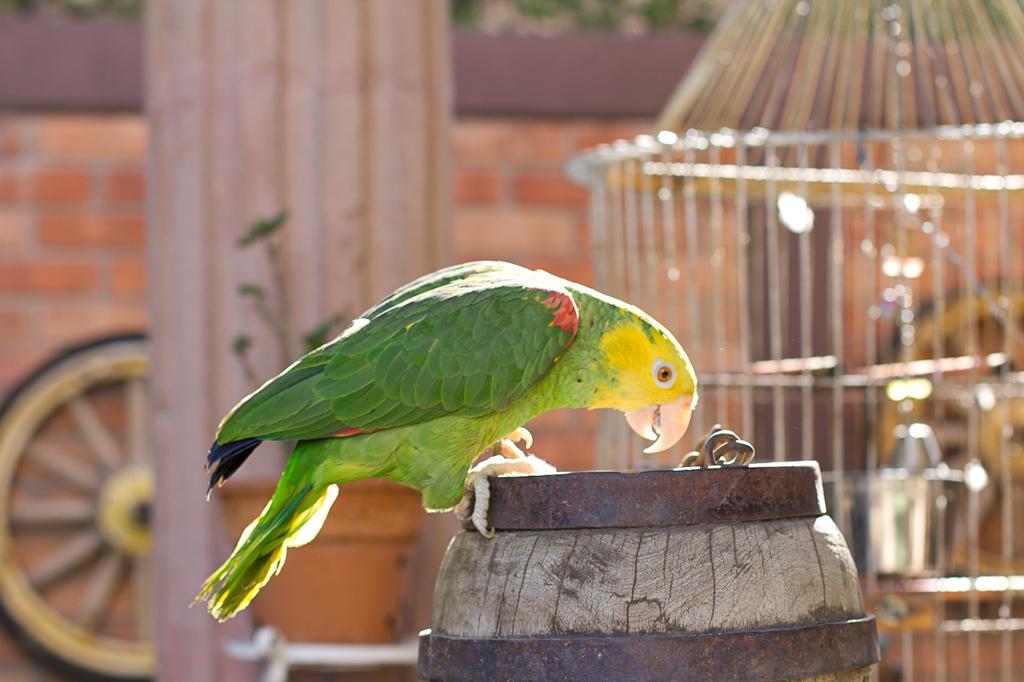How would you summarize this image in a sentence or two? In the middle of the image we can see a parrot on the barrel, in the background we can find a cage and a wheel. 